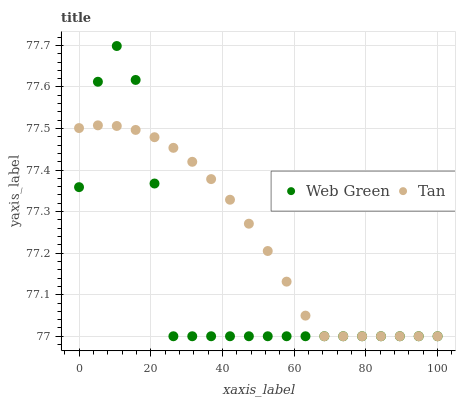Does Web Green have the minimum area under the curve?
Answer yes or no. Yes. Does Tan have the maximum area under the curve?
Answer yes or no. Yes. Does Web Green have the maximum area under the curve?
Answer yes or no. No. Is Tan the smoothest?
Answer yes or no. Yes. Is Web Green the roughest?
Answer yes or no. Yes. Is Web Green the smoothest?
Answer yes or no. No. Does Tan have the lowest value?
Answer yes or no. Yes. Does Web Green have the highest value?
Answer yes or no. Yes. Does Web Green intersect Tan?
Answer yes or no. Yes. Is Web Green less than Tan?
Answer yes or no. No. Is Web Green greater than Tan?
Answer yes or no. No. 